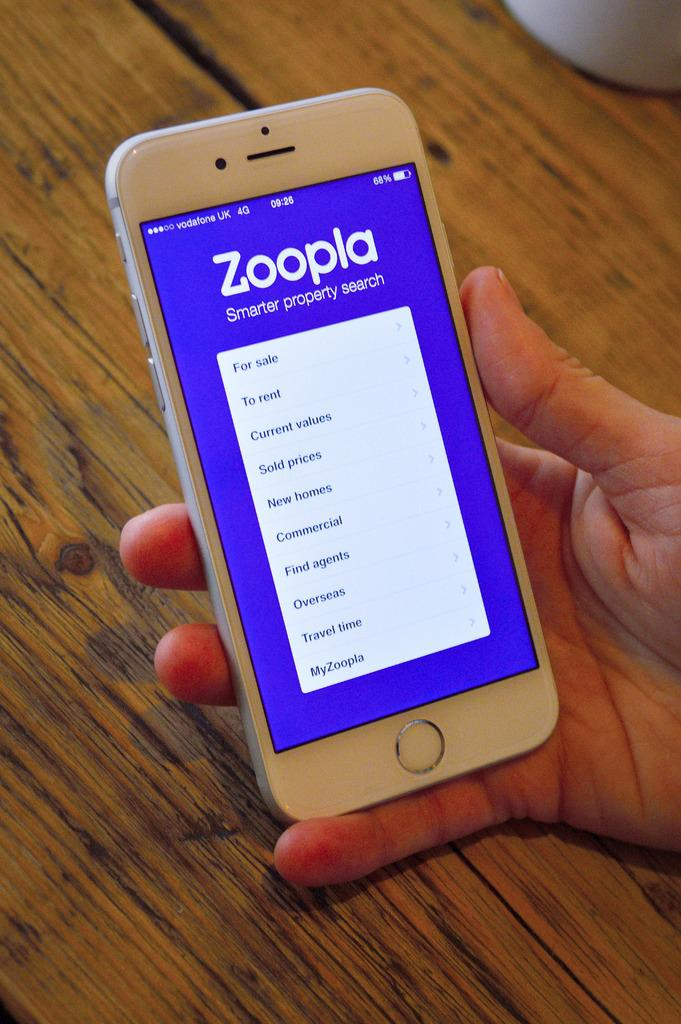Provide a one-sentence caption for the provided image. A hand holding a smartphone showing a property search app. 